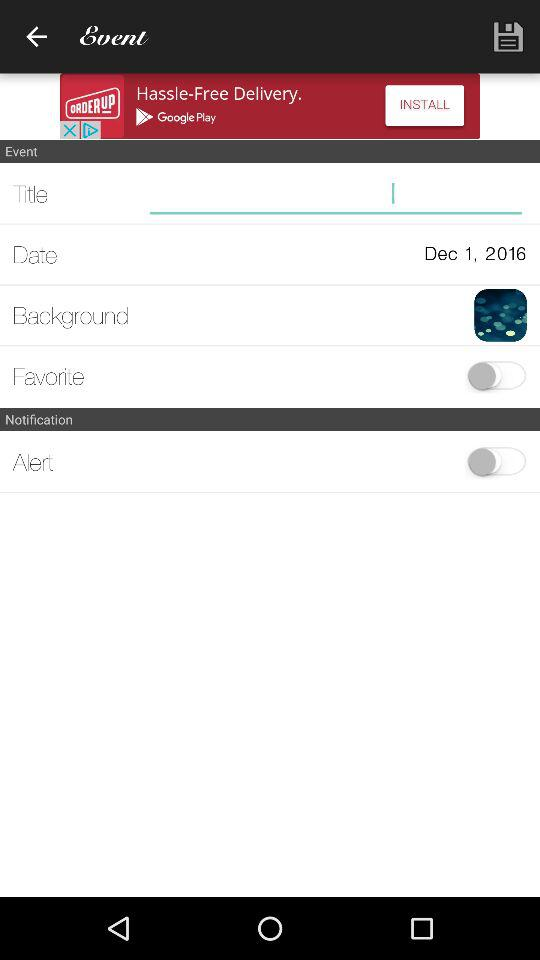How many items have switches?
Answer the question using a single word or phrase. 2 